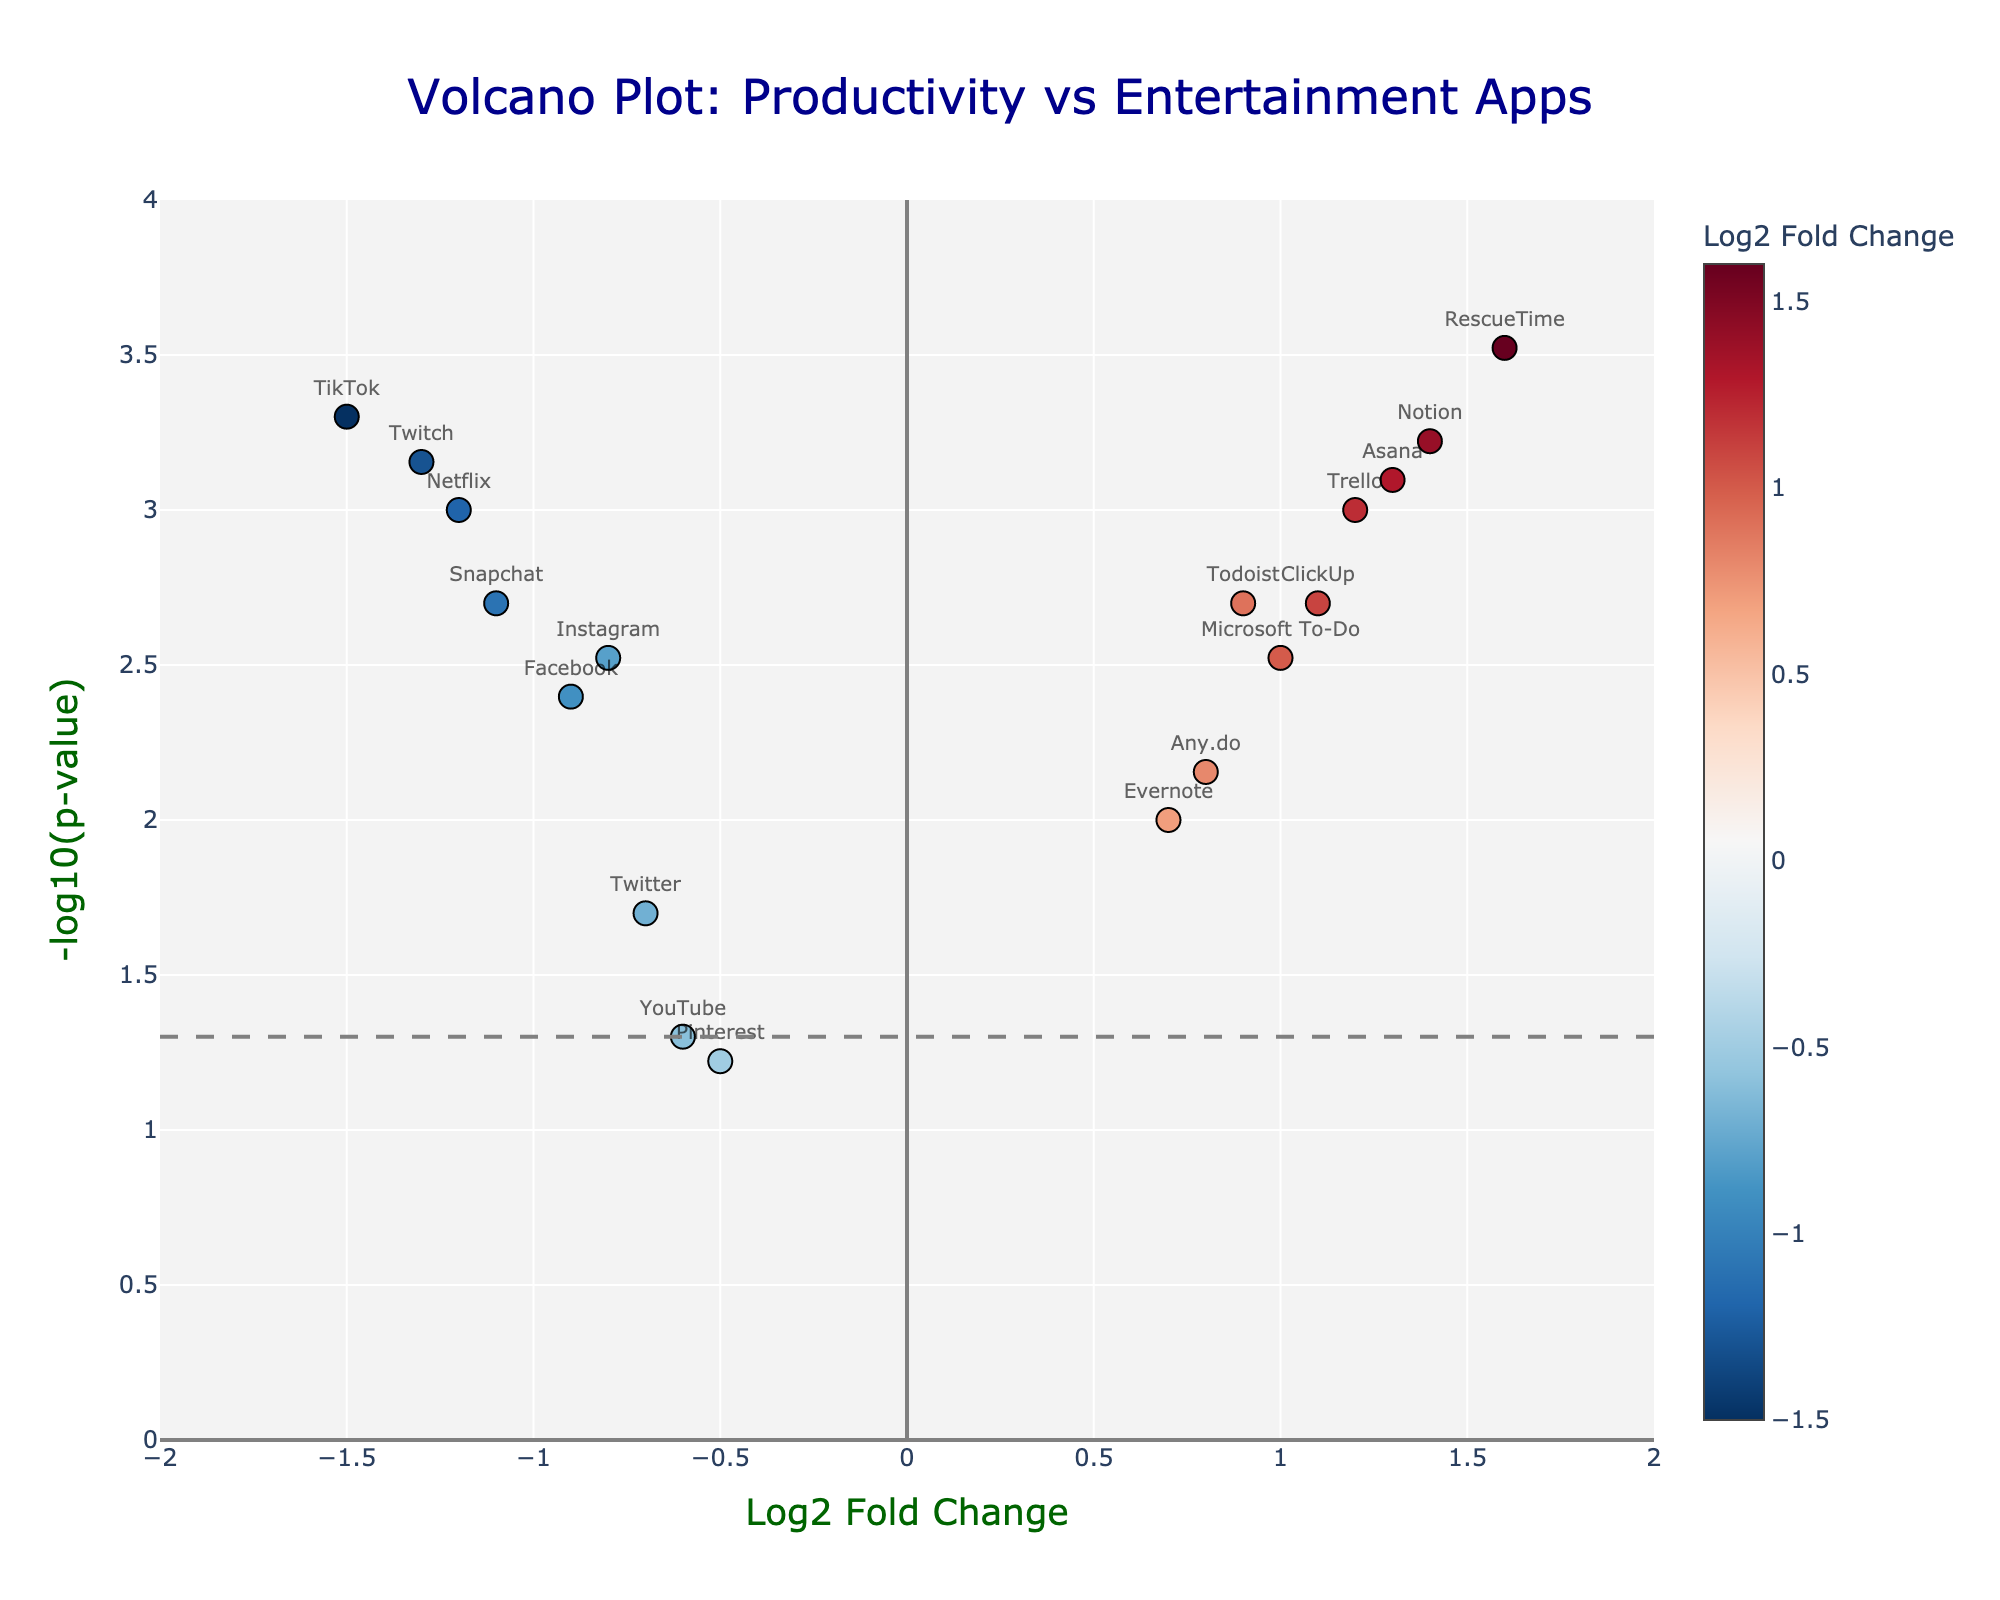What's the main title of the figure? The main title of the plot is prominently displayed at the top of the figure. It provides an overall description of the chart’s purpose.
Answer: "Volcano Plot: Productivity vs Entertainment Apps" What does the y-axis represent? The label of the y-axis is shown vertically along the axis. The y-axis represents the negative logarithm of the p-value, which is depicted as "-log10(p-value)".
Answer: -log10(p-value) How many apps have a Log2 Fold Change greater than 1? To find this, look for points with a Log2 Fold Change value greater than 1. The apps with these values are Trello, Asana, Notion, ClickUp, and RescueTime, which total to 5 apps.
Answer: 5 Which app has the lowest p-value? The app with the highest -log10(p-value) value has the lowest p-value. In this figure, RescueTime has the highest -log10(p-value), indicating the lowest p-value.
Answer: RescueTime Which two apps have nearly the same Log2 Fold Change but different -log10(p-value)? By examining points with similar x-values (Log2 Fold Change) and different y-values (-log10(p-value)), we find that Asana and Trello both have Log2 Fold Change of around 1.2-1.3 but differing -log10(p-value).
Answer: Asana and Trello Which app is almost at the threshold line of significance at 0.05 on the p-value scale? On the y-axis, the threshold line at -log10(0.05) is represented. The point closest to this line is YouTube.
Answer: YouTube How many productivity apps have a p-value less than 0.01 and a Log2 Fold Change greater than 0? Productivity apps with a Log2 Fold Change greater than 0 and a -log10(p-value) greater than 2 (since -log10(0.01)=2) include Trello, Todoist, Asana, Notion, and RescueTime. There are 5 apps.
Answer: 5 Which app has the highest Log2 Fold Change, and what is its -log10(p-value)? By looking for the highest value on the x-axis, we can find Notion with a Log2 Fold Change of 1.4. Its corresponding -log10(p-value) can be seen on the y-axis at around 3.22.
Answer: Notion; 3.22 Name the app with Log2 Fold Change around -1.2 and p-value roughly 0.001. From the data, the point with Log2 Fold Change near -1.2 and -log10(p-value) around 3 corresponds to Netflix.
Answer: Netflix What do the colors of the points indicate in the plot? The colors of the points, varying from red to blue, indicate the Log2 Fold Change. Red represents higher positive changes, while blue represents higher negative changes.
Answer: Log2 Fold Change 